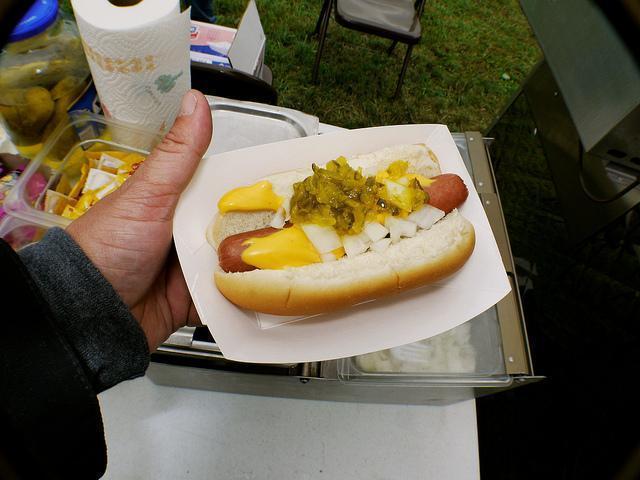How many hot dogs are on the plate?
Give a very brief answer. 1. How many hot dogs are there?
Give a very brief answer. 1. How many people are visible?
Give a very brief answer. 1. How many chairs are in the photo?
Give a very brief answer. 1. 